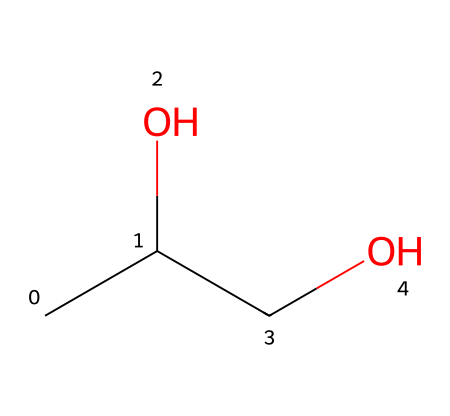What is the molecular formula of propylene glycol? The structure shown has two carbon atoms (C), six hydrogen atoms (H), and two oxygen atoms (O). The molecular formula can be derived by counting each type of atom.
Answer: C3H8O2 How many hydroxyl (-OH) groups are present in the structure? Observing the structure, there are two -OH groups attached to the carbon chain, which are evident by the presence of oxygen atoms with a hydrogen atom.
Answer: 2 What kind of functional groups are present in propylene glycol? The presence of hydroxyl (-OH) groups indicates that propylene glycol is an alcohol. By identifying the functional groups based on the atoms in the structure, we conclude that it contains alcohols.
Answer: alcohols Which part of the structure contributes to its capacity as a preservative? The -OH groups provide moisture retention and antimicrobial properties, which are essential for the preservative function by preventing growth of microbes.
Answer: -OH groups How many carbon atoms are present in propylene glycol? The structure shows a carbon chain that consists of three carbon atoms. Counting these confirms there are three carbons.
Answer: 3 What is the primary reason propylene glycol is used in dermatological preparations? Propylene glycol's properties, particularly its ability to retain moisture and its low toxicity, make it ideal for skin applications, enhancing product stability and skin hydration.
Answer: moisture retention 